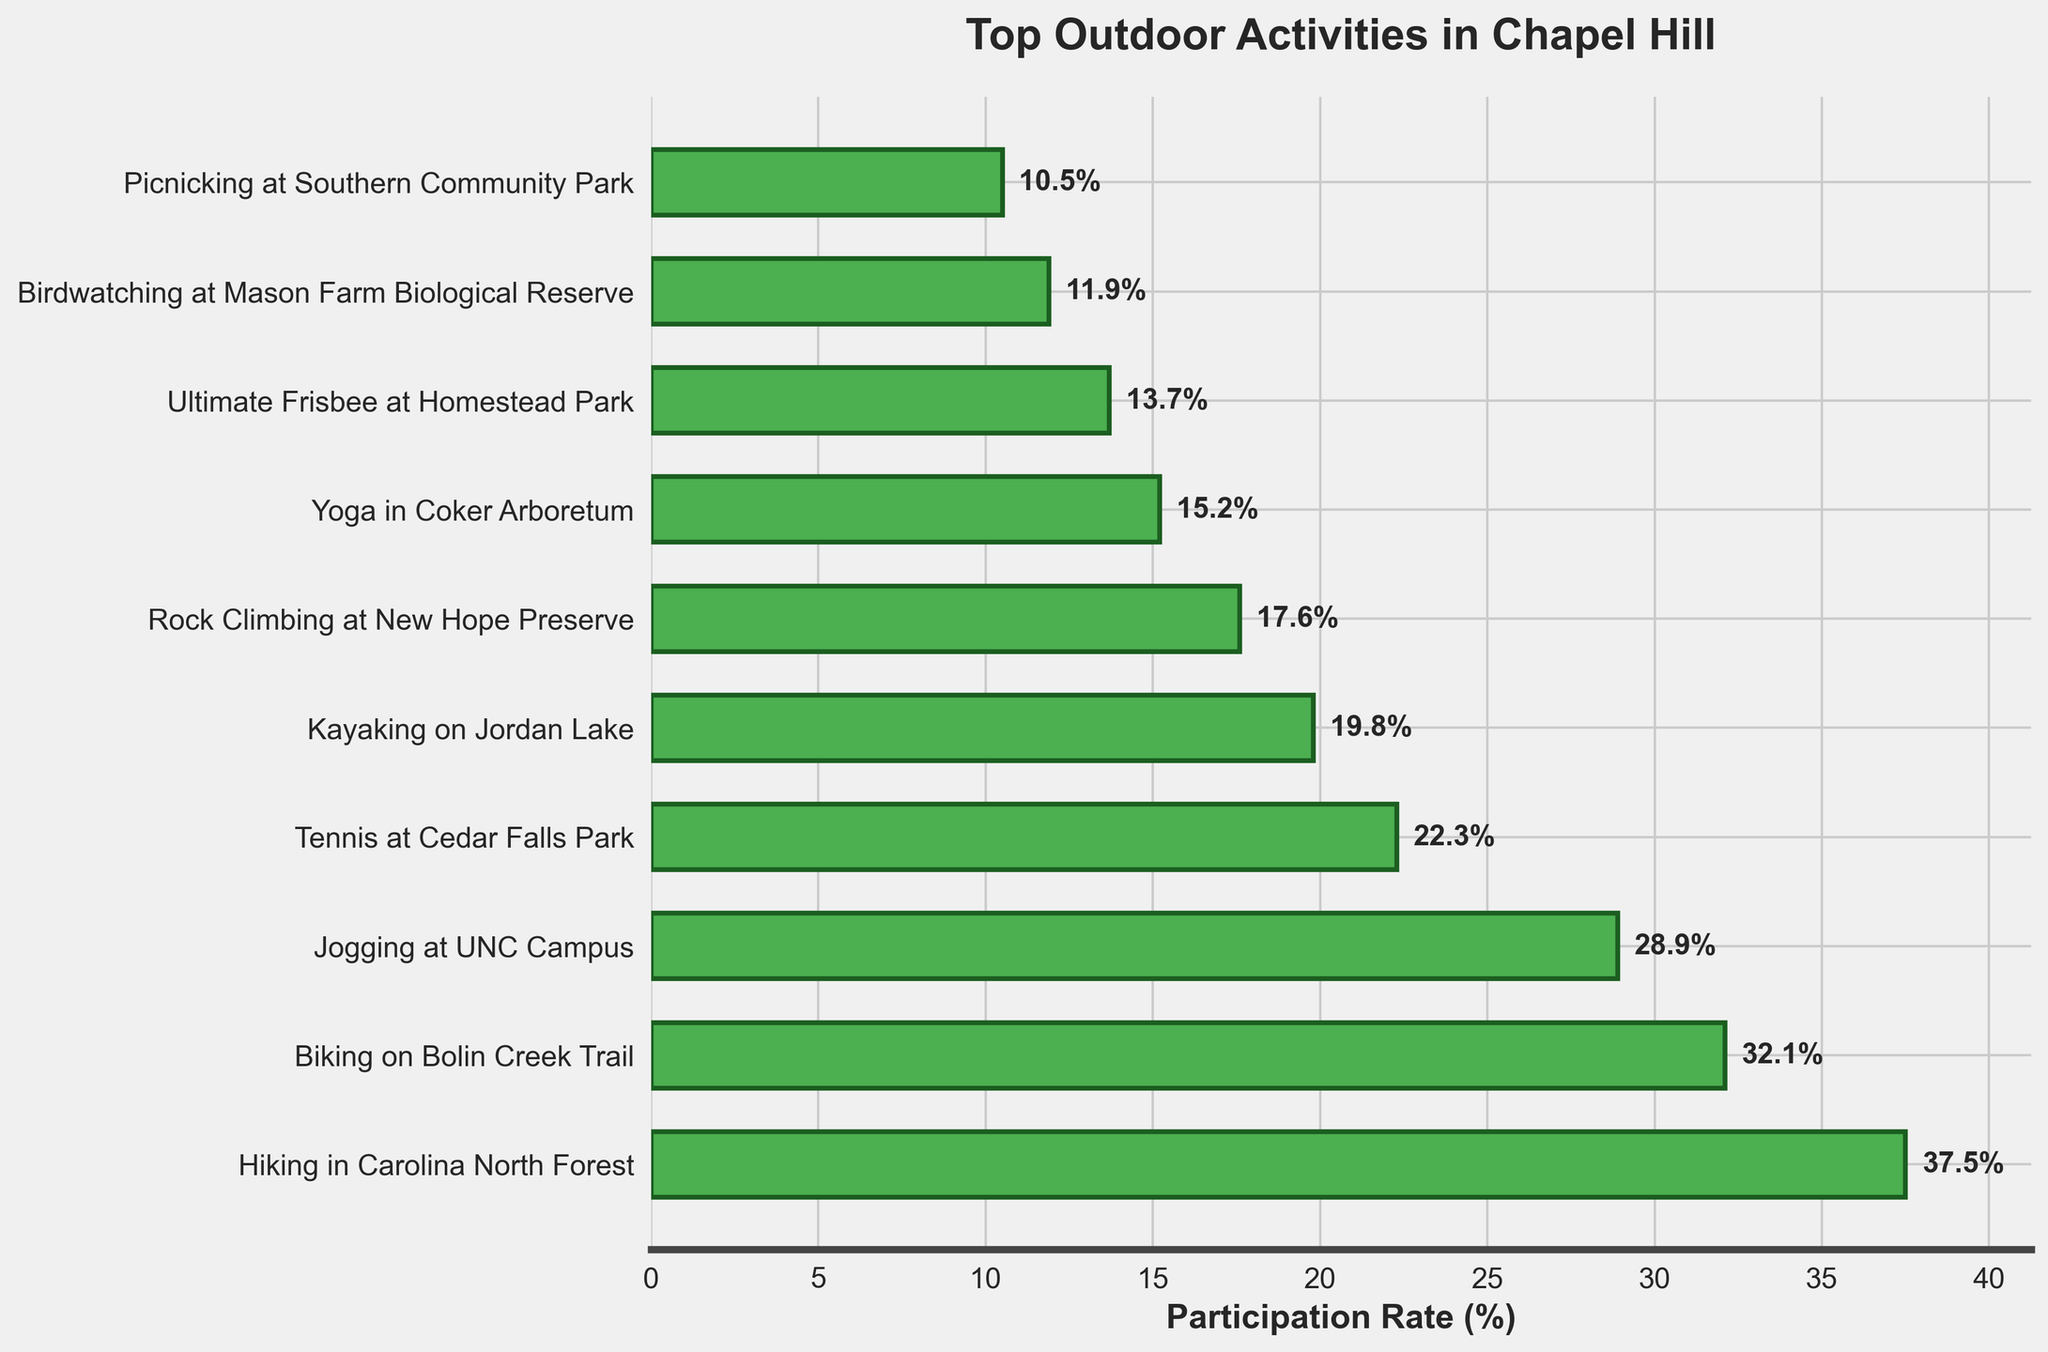What's the most popular outdoor activity in Chapel Hill? The highest participation rate indicates the most popular activity. The activity with the highest bar in the bar chart is "Hiking in Carolina North Forest."
Answer: Hiking in Carolina North Forest What’s the difference in participation rate between the most and least popular activities? Subtract the participation rate of the least popular activity from the most popular activity. The most popular, "Hiking in Carolina North Forest," has a rate of 37.5%, and the least popular, "Picnicking at Southern Community Park," has a rate of 10.5%. So, 37.5 - 10.5 = 27.
Answer: 27% Which activities have a participation rate greater than 20%? Look for activities with bars extending past the 20% mark. They are "Hiking in Carolina North Forest" (37.5%), "Biking on Bolin Creek Trail" (32.1%), "Jogging at UNC Campus" (28.9%), and "Tennis at Cedar Falls Park" (22.3%).
Answer: Hiking in Carolina North Forest, Biking on Bolin Creek Trail, Jogging at UNC Campus, Tennis at Cedar Falls Park What’s the total participation rate for activities with rates below 20%? Sum the participation rates of the activities: "Kayaking on Jordan Lake" (19.8%), "Rock Climbing at New Hope Preserve" (17.6%), "Yoga in Coker Arboretum" (15.2%), "Ultimate Frisbee at Homestead Park" (13.7%), "Birdwatching at Mason Farm Biological Reserve" (11.9%), "Picnicking at Southern Community Park" (10.5%). This results in 19.8 + 17.6 + 15.2 + 13.7 + 11.9 + 10.5 = 88.7%.
Answer: 88.7% Which activity has the closest participation rate to 20%? Identify the activity with the rate closest to 20%. "Tennis at Cedar Falls Park" at 22.3% is the closest to 20% as compared to "Kayaking on Jordan Lake" at 19.8%. The difference is 22.3 - 20 = 2.3 and 20 - 19.8 = 0.2. Since 0.2 is smaller, the closer rate is 19.8%.
Answer: Kayaking on Jordan Lake What’s the combined participation rate of "Jogging at UNC Campus" and "Yoga in Coker Arboretum"? Add the participation rates of these two activities: "Jogging at UNC Campus" (28.9%) and "Yoga in Coker Arboretum" (15.2%). This gives 28.9 + 15.2 = 44.1%.
Answer: 44.1% List the activities in ascending order of their participation rates. Arrange the activities based on their participation rates from lowest to highest. The order is: "Picnicking at Southern Community Park" (10.5%), "Birdwatching at Mason Farm Biological Reserve" (11.9%), "Ultimate Frisbee at Homestead Park" (13.7%), "Yoga in Coker Arboretum" (15.2%), "Rock Climbing at New Hope Preserve" (17.6%), "Kayaking on Jordan Lake" (19.8%), "Tennis at Cedar Falls Park" (22.3%), "Jogging at UNC Campus" (28.9%), "Biking on Bolin Creek Trail" (32.1%), "Hiking in Carolina North Forest" (37.5%).
Answer: Picnicking at Southern Community Park, Birdwatching at Mason Farm Biological Reserve, Ultimate Frisbee at Homestead Park, Yoga in Coker Arboretum, Rock Climbing at New Hope Preserve, Kayaking on Jordan Lake, Tennis at Cedar Falls Park, Jogging at UNC Campus, Biking on Bolin Creek Trail, Hiking in Carolina North Forest 